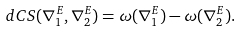Convert formula to latex. <formula><loc_0><loc_0><loc_500><loc_500>d C S ( \nabla ^ { E } _ { 1 } , \nabla ^ { E } _ { 2 } ) = \omega ( \nabla ^ { E } _ { 1 } ) - \omega ( \nabla ^ { E } _ { 2 } ) .</formula> 